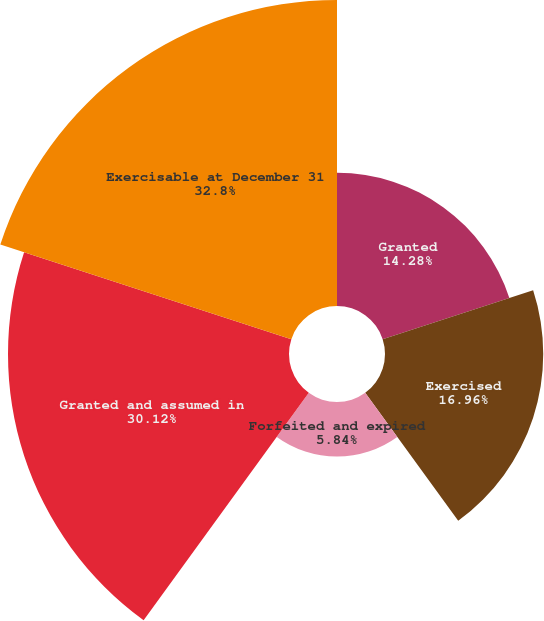Convert chart to OTSL. <chart><loc_0><loc_0><loc_500><loc_500><pie_chart><fcel>Granted<fcel>Exercised<fcel>Forfeited and expired<fcel>Granted and assumed in<fcel>Exercisable at December 31<nl><fcel>14.28%<fcel>16.96%<fcel>5.84%<fcel>30.12%<fcel>32.8%<nl></chart> 